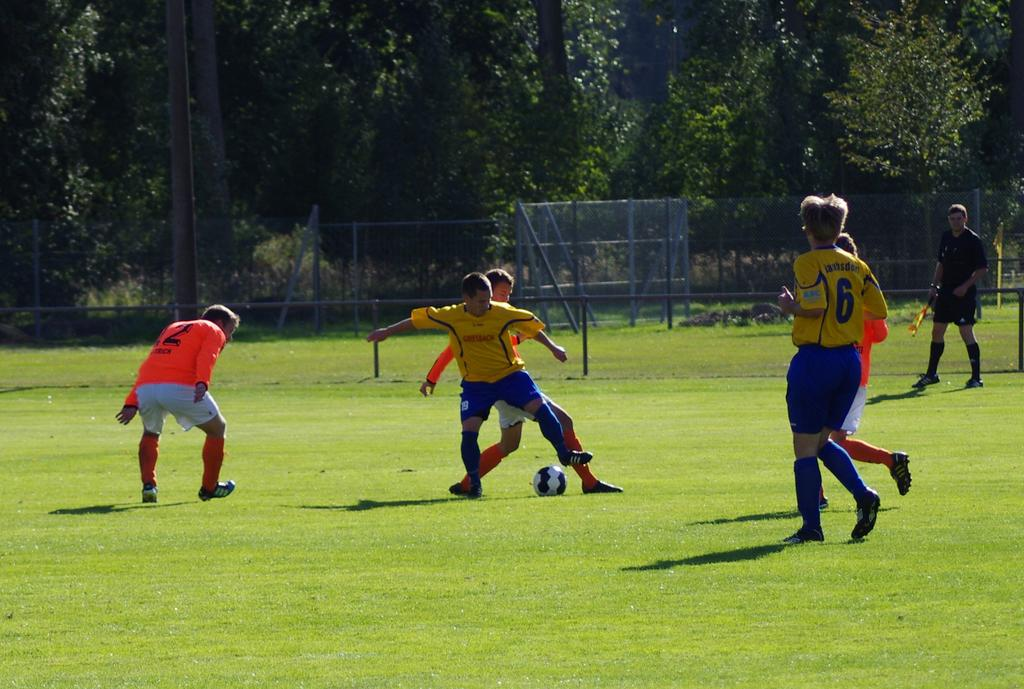<image>
Render a clear and concise summary of the photo. Players on the soccer field one with 6 on their shirt. 